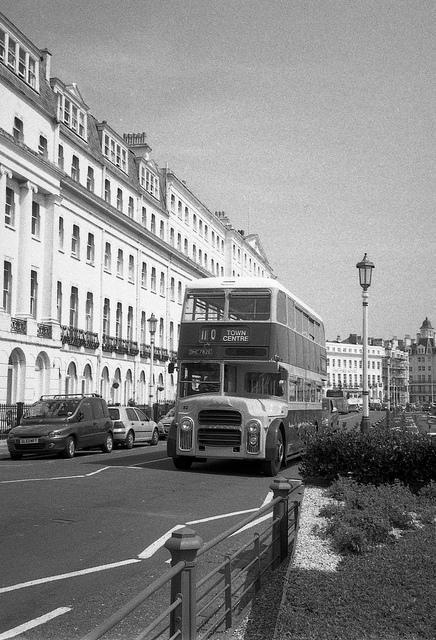How many men are there?
Give a very brief answer. 0. 